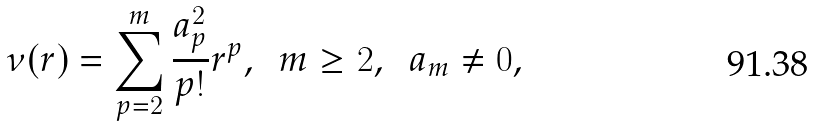<formula> <loc_0><loc_0><loc_500><loc_500>\nu ( r ) = \sum _ { p = 2 } ^ { m } \frac { a _ { p } ^ { 2 } } { p ! } r ^ { p } , \ \ m \geq 2 , \ \ a _ { m } \ne 0 ,</formula> 